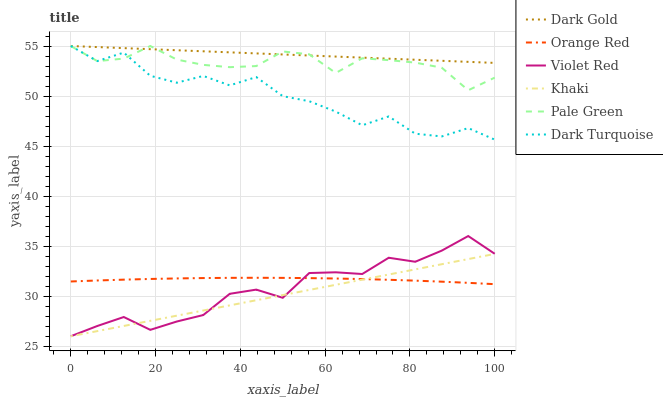Does Khaki have the minimum area under the curve?
Answer yes or no. Yes. Does Dark Gold have the maximum area under the curve?
Answer yes or no. Yes. Does Dark Gold have the minimum area under the curve?
Answer yes or no. No. Does Khaki have the maximum area under the curve?
Answer yes or no. No. Is Dark Gold the smoothest?
Answer yes or no. Yes. Is Dark Turquoise the roughest?
Answer yes or no. Yes. Is Khaki the smoothest?
Answer yes or no. No. Is Khaki the roughest?
Answer yes or no. No. Does Violet Red have the lowest value?
Answer yes or no. Yes. Does Dark Gold have the lowest value?
Answer yes or no. No. Does Pale Green have the highest value?
Answer yes or no. Yes. Does Khaki have the highest value?
Answer yes or no. No. Is Khaki less than Pale Green?
Answer yes or no. Yes. Is Pale Green greater than Orange Red?
Answer yes or no. Yes. Does Pale Green intersect Dark Gold?
Answer yes or no. Yes. Is Pale Green less than Dark Gold?
Answer yes or no. No. Is Pale Green greater than Dark Gold?
Answer yes or no. No. Does Khaki intersect Pale Green?
Answer yes or no. No. 